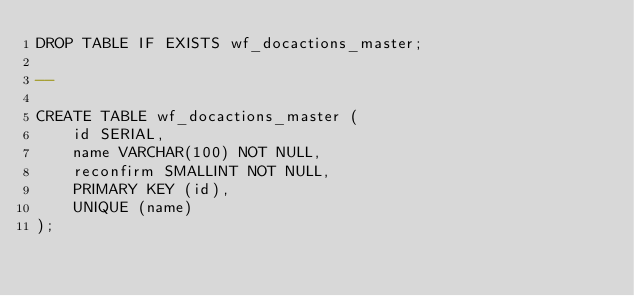<code> <loc_0><loc_0><loc_500><loc_500><_SQL_>DROP TABLE IF EXISTS wf_docactions_master;

--

CREATE TABLE wf_docactions_master (
    id SERIAL,
    name VARCHAR(100) NOT NULL,
    reconfirm SMALLINT NOT NULL,
    PRIMARY KEY (id),
    UNIQUE (name)
);
</code> 